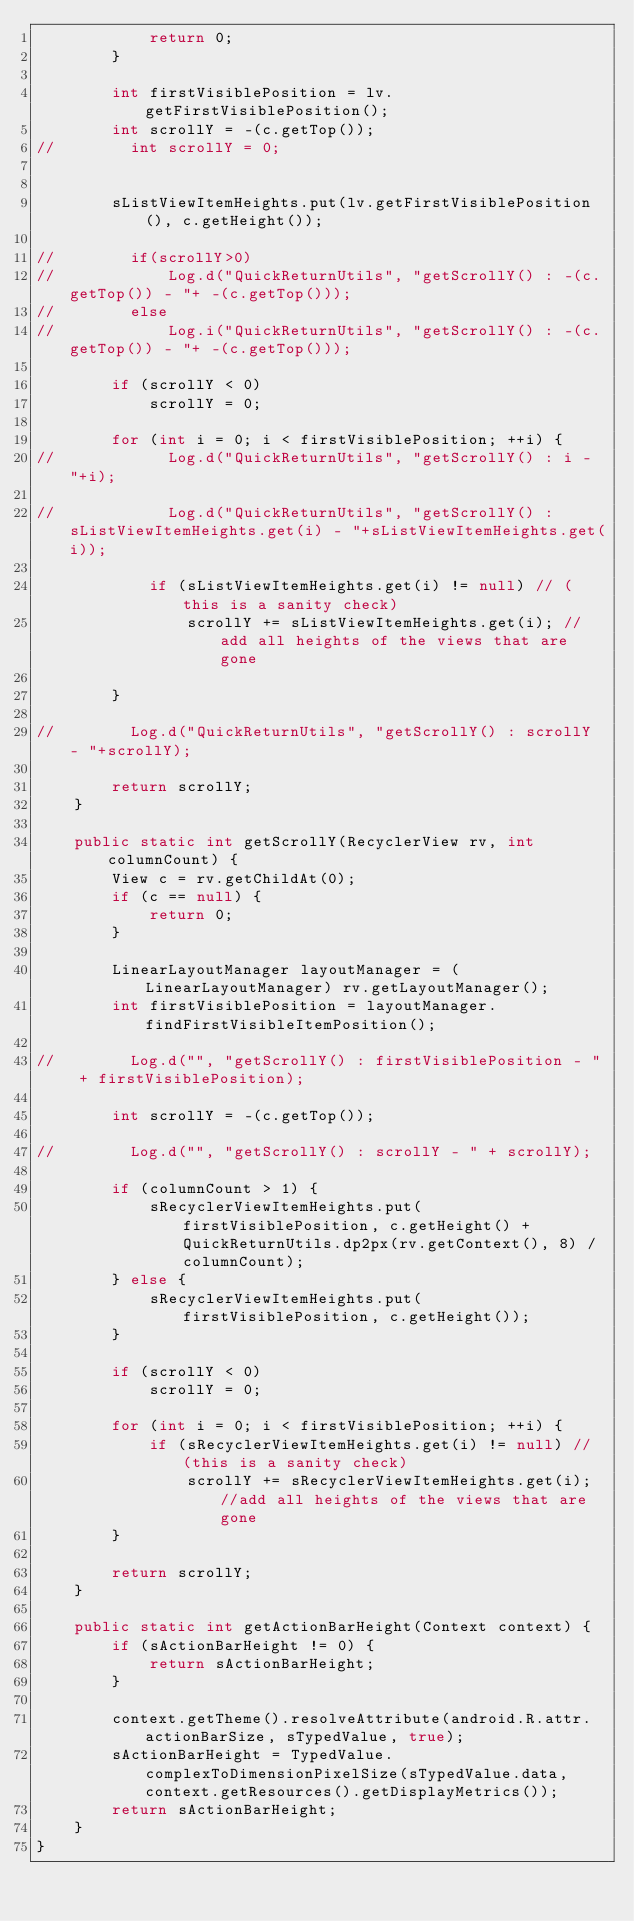<code> <loc_0><loc_0><loc_500><loc_500><_Java_>            return 0;
        }

        int firstVisiblePosition = lv.getFirstVisiblePosition();
        int scrollY = -(c.getTop());
//        int scrollY = 0;


        sListViewItemHeights.put(lv.getFirstVisiblePosition(), c.getHeight());

//        if(scrollY>0)
//            Log.d("QuickReturnUtils", "getScrollY() : -(c.getTop()) - "+ -(c.getTop()));
//        else
//            Log.i("QuickReturnUtils", "getScrollY() : -(c.getTop()) - "+ -(c.getTop()));

        if (scrollY < 0)
            scrollY = 0;

        for (int i = 0; i < firstVisiblePosition; ++i) {
//            Log.d("QuickReturnUtils", "getScrollY() : i - "+i);

//            Log.d("QuickReturnUtils", "getScrollY() : sListViewItemHeights.get(i) - "+sListViewItemHeights.get(i));

            if (sListViewItemHeights.get(i) != null) // (this is a sanity check)
                scrollY += sListViewItemHeights.get(i); //add all heights of the views that are gone

        }

//        Log.d("QuickReturnUtils", "getScrollY() : scrollY - "+scrollY);

        return scrollY;
    }

    public static int getScrollY(RecyclerView rv, int columnCount) {
        View c = rv.getChildAt(0);
        if (c == null) {
            return 0;
        }

        LinearLayoutManager layoutManager = (LinearLayoutManager) rv.getLayoutManager();
        int firstVisiblePosition = layoutManager.findFirstVisibleItemPosition();

//        Log.d("", "getScrollY() : firstVisiblePosition - " + firstVisiblePosition);

        int scrollY = -(c.getTop());

//        Log.d("", "getScrollY() : scrollY - " + scrollY);

        if (columnCount > 1) {
            sRecyclerViewItemHeights.put(firstVisiblePosition, c.getHeight() + QuickReturnUtils.dp2px(rv.getContext(), 8) / columnCount);
        } else {
            sRecyclerViewItemHeights.put(firstVisiblePosition, c.getHeight());
        }

        if (scrollY < 0)
            scrollY = 0;

        for (int i = 0; i < firstVisiblePosition; ++i) {
            if (sRecyclerViewItemHeights.get(i) != null) // (this is a sanity check)
                scrollY += sRecyclerViewItemHeights.get(i); //add all heights of the views that are gone
        }

        return scrollY;
    }

    public static int getActionBarHeight(Context context) {
        if (sActionBarHeight != 0) {
            return sActionBarHeight;
        }

        context.getTheme().resolveAttribute(android.R.attr.actionBarSize, sTypedValue, true);
        sActionBarHeight = TypedValue.complexToDimensionPixelSize(sTypedValue.data, context.getResources().getDisplayMetrics());
        return sActionBarHeight;
    }
}
</code> 